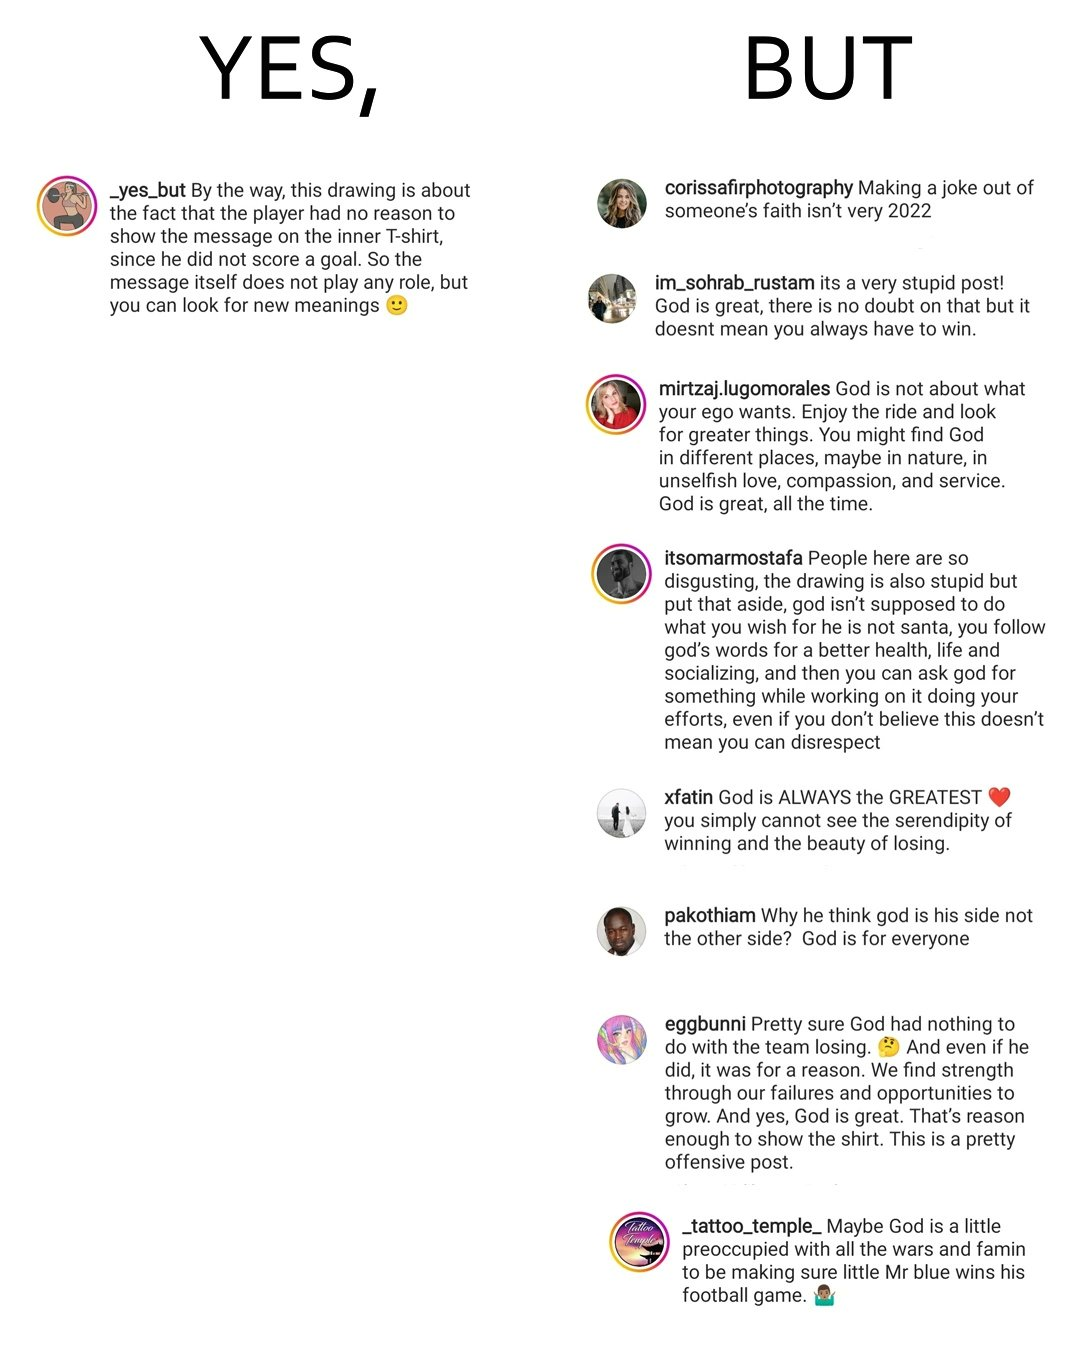Explain the humor or irony in this image. The image is ironic, because the person in the first image is trying to explain about some content posted by it and in the second image the people in the comment section has misinterpreted the posted and are declaring or criticising it as an offensive joke rather than knowing the real meaning or logic behind the post 